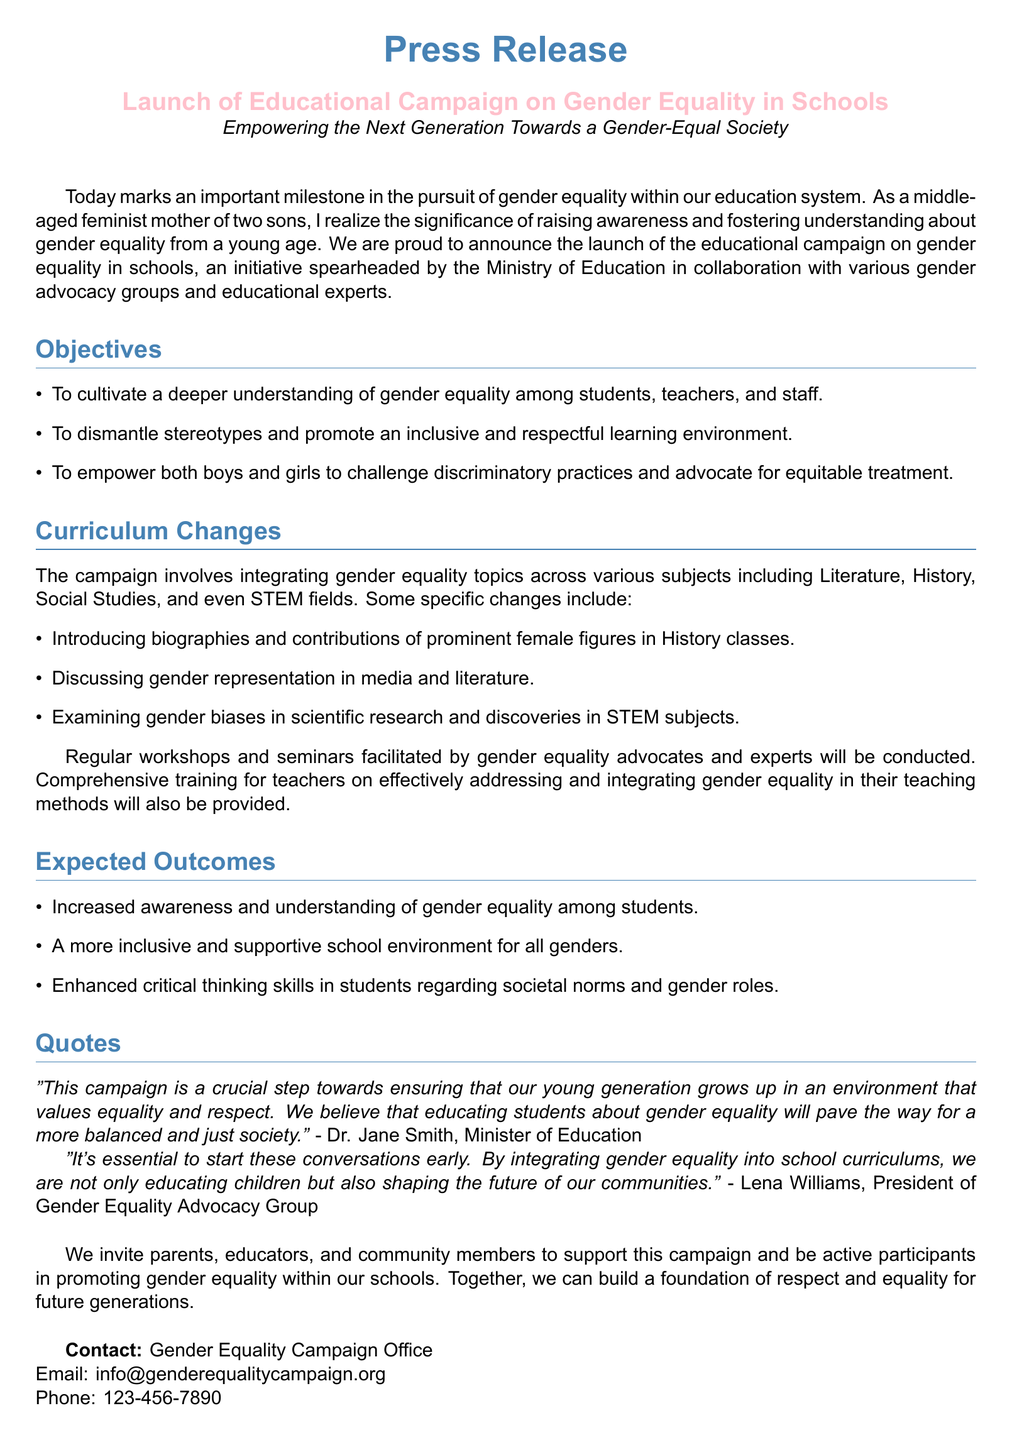What is the title of the campaign? The title of the campaign as stated in the document is related to promoting gender equality in schools.
Answer: Educational Campaign on Gender Equality in Schools Who is the Minister of Education quoted in the document? The document includes a quote from the Minister of Education, identifying her by name.
Answer: Dr. Jane Smith What is one of the objectives of the campaign? The objectives focus on enhancing understanding and promoting respect concerning gender equality among students.
Answer: To dismantle stereotypes What subject will include gender equality topics as part of the curriculum changes? The document specifies various subjects where gender equality will be integrated.
Answer: Literature What is the expected outcome related to school environments? This aspect of the expected outcomes addresses the learning context for students.
Answer: A more inclusive and supportive school environment for all genders Who is the President of the Gender Equality Advocacy Group? The document includes a quote from a pertinent individual associated with the initiative.
Answer: Lena Williams How will teachers receive training regarding gender equality? The document describes the training method and its purpose for educators.
Answer: Comprehensive training for teachers What is the contact email provided in the document? The contact details for the campaign include an email address for inquiries.
Answer: info@genderequalitycampaign.org When was the campaign launched? The document states the significance of the launch without a specific date or year provided but indicates that it is today.
Answer: Today 